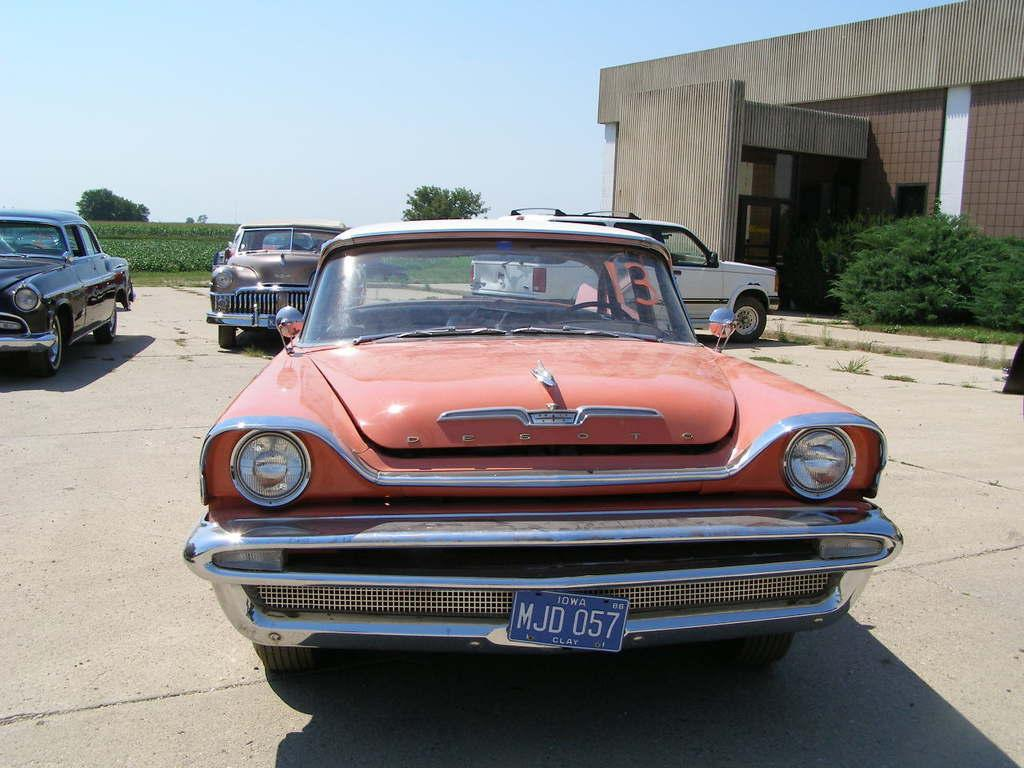What can be seen on the road in the image? There are cars on the road in the image. What is located to the right side of the image? There is a building to the right side of the image. What type of vegetation is present in the image? There are trees and plants in the image. What is visible at the top of the image? The sky is visible at the top of the image. How many baseballs can be seen in the image? There are no baseballs present in the image. Are there any boys playing in the image? There is no mention of boys or any play activity in the image. Can you see any cattle in the image? There is no mention of cattle or any animals in the image. 